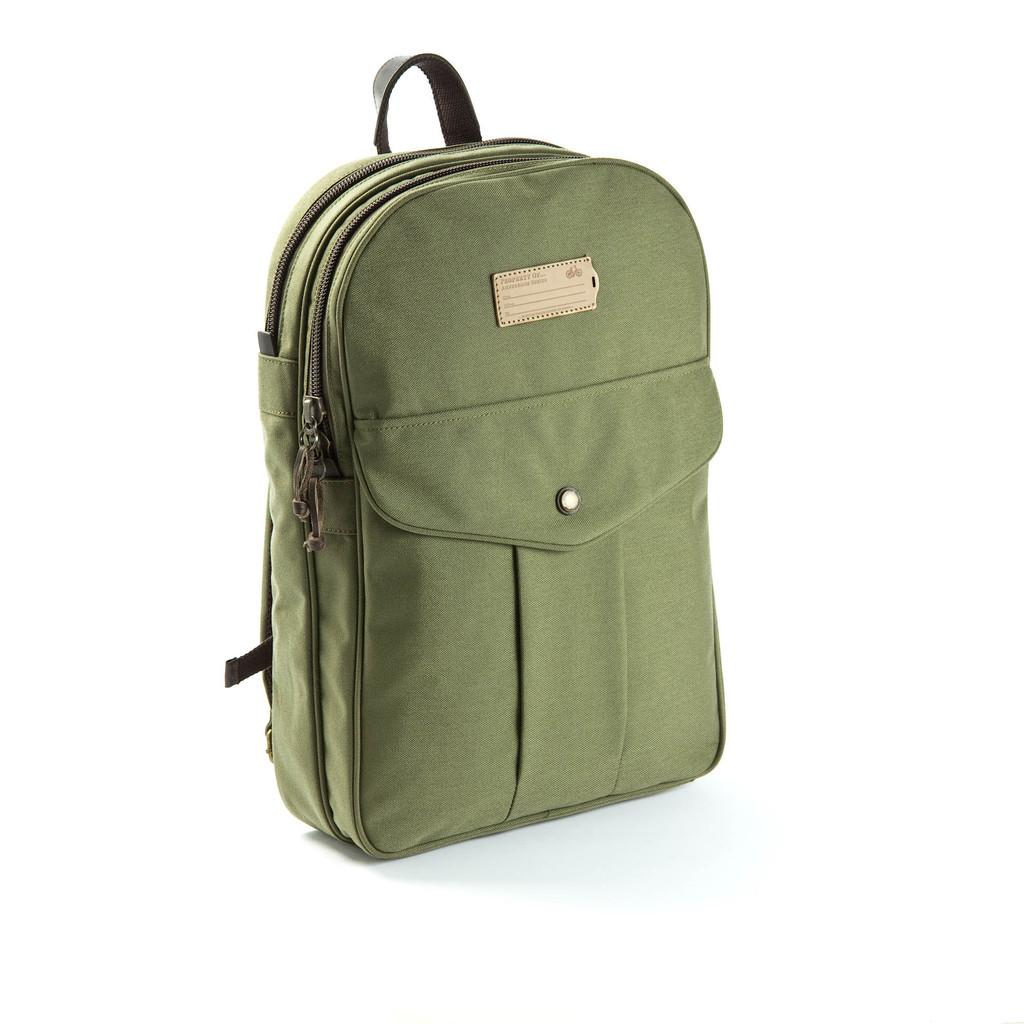What object is present in the image? There is a bag in the image. What color is the bag? The bag is in army green color. What is the color of the background in the image? The background of the image is white in color. Can you see any snow falling in the image? There is no snow present in the image, as the background is white and there is no indication of snowfall. Is there a gun visible in the image? There is no gun present in the image; it only features a bag and a white background. 